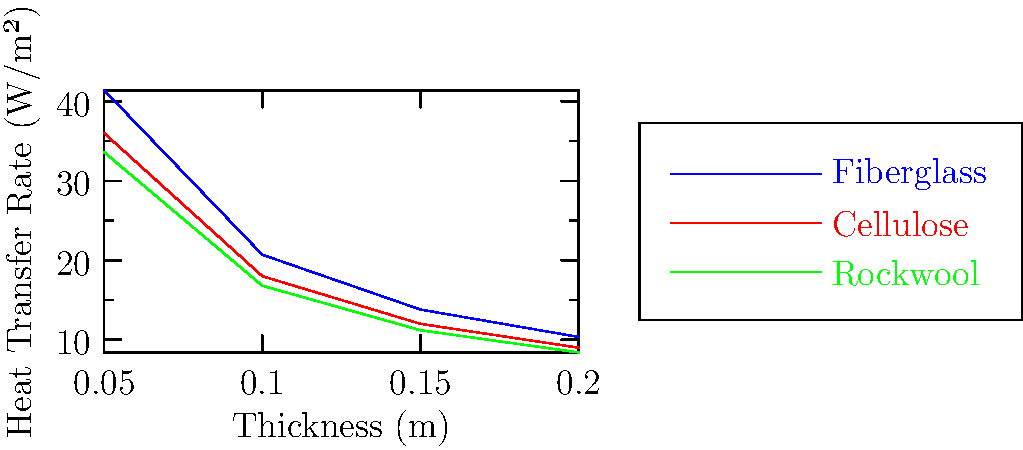Given the graph showing heat transfer rates through different insulation materials at varying thicknesses, which material demonstrates the lowest heat transfer rate at a thickness of 0.15 m? Additionally, calculate the percentage difference in heat transfer rate between the best and worst performing materials at this thickness. To solve this problem, we'll follow these steps:

1. Identify the heat transfer rates for each material at 0.15 m thickness:
   - Fiberglass: 13.8 W/m²
   - Cellulose: 12.0 W/m²
   - Rockwool: 11.2 W/m²

2. Determine the material with the lowest heat transfer rate:
   Rockwool has the lowest rate at 11.2 W/m².

3. Calculate the percentage difference between the best (Rockwool) and worst (Fiberglass) performing materials:

   Percentage difference = $\frac{\text{Difference}}{\text{Average}} \times 100\%$

   $\text{Difference} = 13.8 - 11.2 = 2.6$ W/m²
   $\text{Average} = \frac{13.8 + 11.2}{2} = 12.5$ W/m²

   Percentage difference = $\frac{2.6}{12.5} \times 100\% = 20.8\%$

Therefore, Rockwool demonstrates the lowest heat transfer rate at 0.15 m thickness, and the percentage difference between the best and worst performing materials is 20.8%.
Answer: Rockwool; 20.8% 